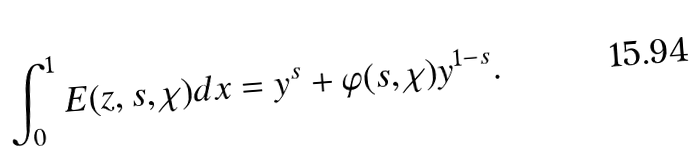Convert formula to latex. <formula><loc_0><loc_0><loc_500><loc_500>\int _ { 0 } ^ { 1 } E ( z , s , \chi ) d x = y ^ { s } + \varphi ( s , \chi ) y ^ { 1 - s } .</formula> 